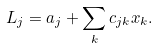Convert formula to latex. <formula><loc_0><loc_0><loc_500><loc_500>L _ { j } = a _ { j } + \sum _ { k } c _ { j k } x _ { k } .</formula> 